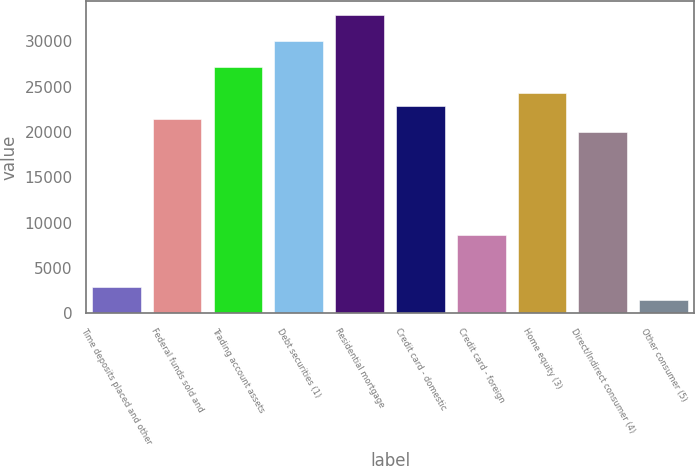Convert chart. <chart><loc_0><loc_0><loc_500><loc_500><bar_chart><fcel>Time deposits placed and other<fcel>Federal funds sold and<fcel>Trading account assets<fcel>Debt securities (1)<fcel>Residential mortgage<fcel>Credit card - domestic<fcel>Credit card - foreign<fcel>Home equity (3)<fcel>Direct/Indirect consumer (4)<fcel>Other consumer (5)<nl><fcel>2903<fcel>21447.5<fcel>27153.5<fcel>30006.5<fcel>32859.5<fcel>22874<fcel>8609<fcel>24300.5<fcel>20021<fcel>1476.5<nl></chart> 